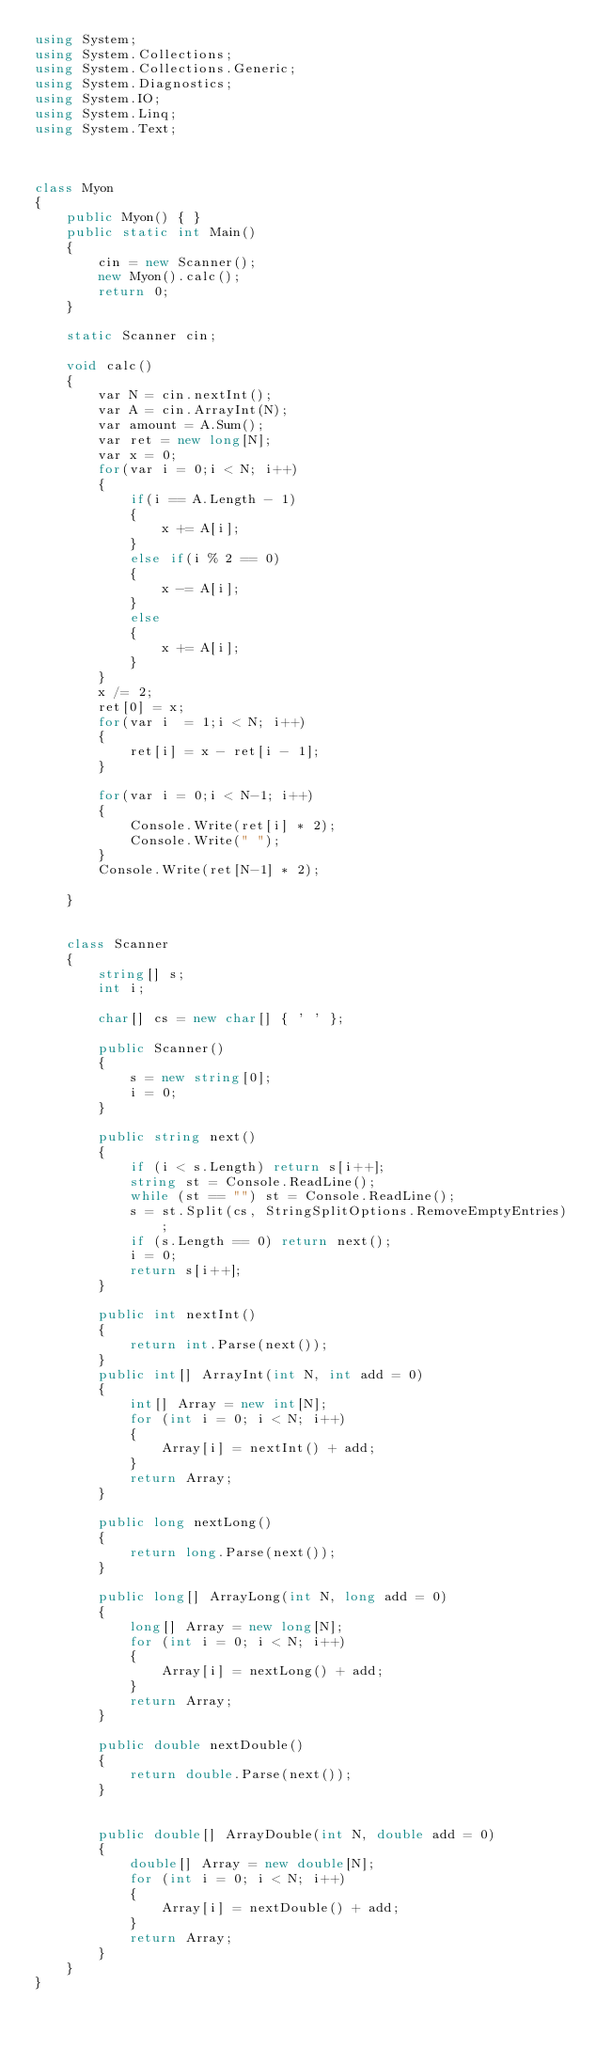Convert code to text. <code><loc_0><loc_0><loc_500><loc_500><_C#_>using System;
using System.Collections;
using System.Collections.Generic;
using System.Diagnostics;
using System.IO;
using System.Linq;
using System.Text;



class Myon
{
    public Myon() { }
    public static int Main()
    {
        cin = new Scanner();
        new Myon().calc();
        return 0;
    }

    static Scanner cin;

    void calc()
    {
        var N = cin.nextInt();
        var A = cin.ArrayInt(N);
        var amount = A.Sum();
        var ret = new long[N];
        var x = 0;
        for(var i = 0;i < N; i++)
        {
            if(i == A.Length - 1)
            {
                x += A[i];
            }
            else if(i % 2 == 0)
            {
                x -= A[i];
            }
            else
            {
                x += A[i];
            }
        }
        x /= 2;
        ret[0] = x;
        for(var i  = 1;i < N; i++)
        {
            ret[i] = x - ret[i - 1];
        }

        for(var i = 0;i < N-1; i++)
        {
            Console.Write(ret[i] * 2);
            Console.Write(" ");
        }
        Console.Write(ret[N-1] * 2);

    }


    class Scanner
    {
        string[] s;
        int i;

        char[] cs = new char[] { ' ' };

        public Scanner()
        {
            s = new string[0];
            i = 0;
        }

        public string next()
        {
            if (i < s.Length) return s[i++];
            string st = Console.ReadLine();
            while (st == "") st = Console.ReadLine();
            s = st.Split(cs, StringSplitOptions.RemoveEmptyEntries);
            if (s.Length == 0) return next();
            i = 0;
            return s[i++];
        }

        public int nextInt()
        {
            return int.Parse(next());
        }
        public int[] ArrayInt(int N, int add = 0)
        {
            int[] Array = new int[N];
            for (int i = 0; i < N; i++)
            {
                Array[i] = nextInt() + add;
            }
            return Array;
        }

        public long nextLong()
        {
            return long.Parse(next());
        }

        public long[] ArrayLong(int N, long add = 0)
        {
            long[] Array = new long[N];
            for (int i = 0; i < N; i++)
            {
                Array[i] = nextLong() + add;
            }
            return Array;
        }

        public double nextDouble()
        {
            return double.Parse(next());
        }


        public double[] ArrayDouble(int N, double add = 0)
        {
            double[] Array = new double[N];
            for (int i = 0; i < N; i++)
            {
                Array[i] = nextDouble() + add;
            }
            return Array;
        }
    }
}</code> 